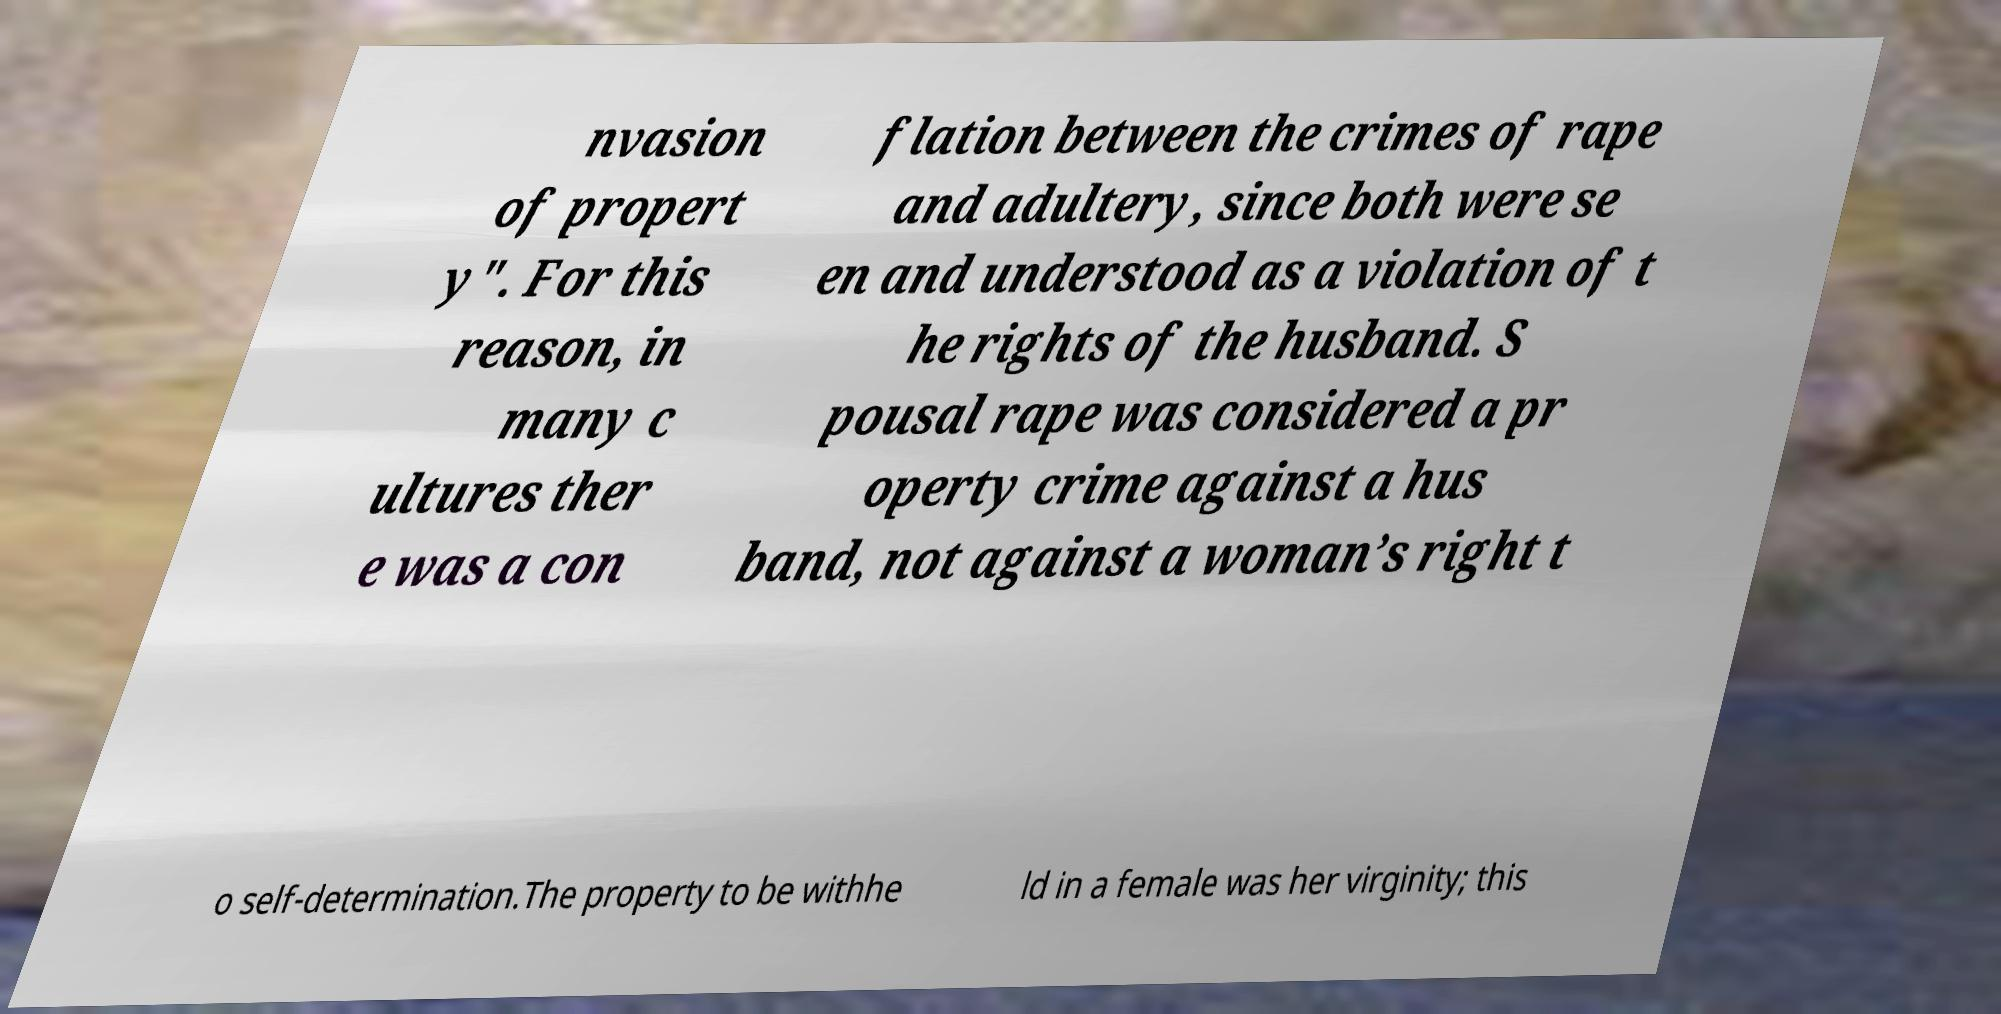Can you accurately transcribe the text from the provided image for me? nvasion of propert y". For this reason, in many c ultures ther e was a con flation between the crimes of rape and adultery, since both were se en and understood as a violation of t he rights of the husband. S pousal rape was considered a pr operty crime against a hus band, not against a woman’s right t o self-determination.The property to be withhe ld in a female was her virginity; this 